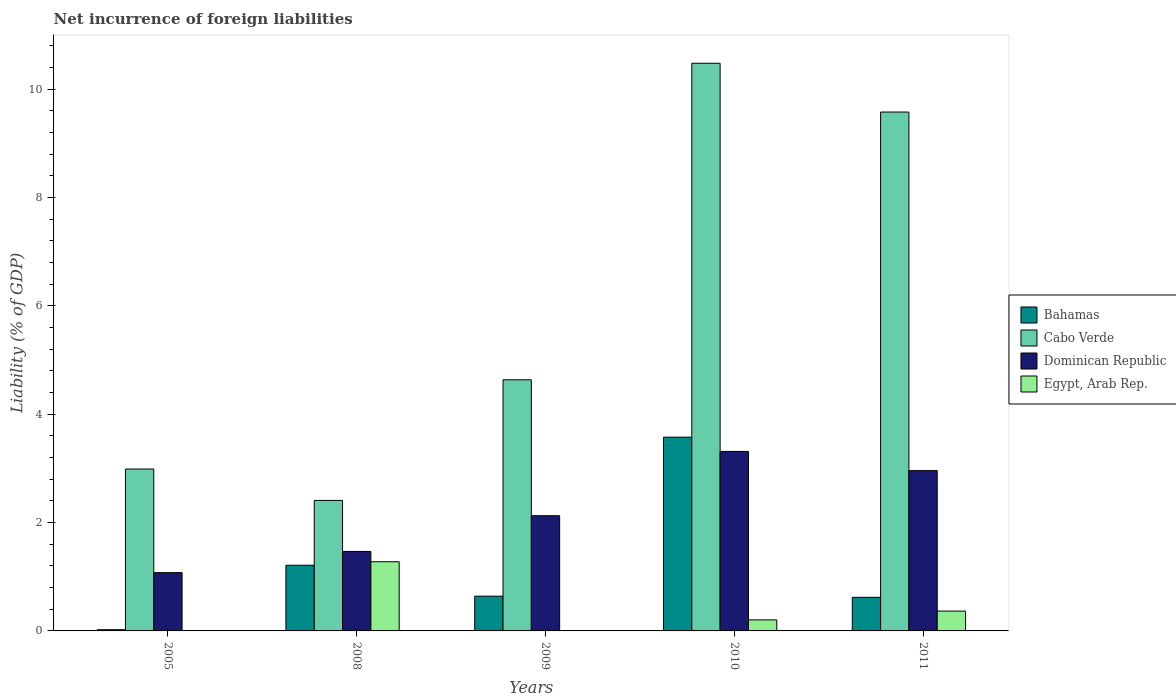How many different coloured bars are there?
Offer a very short reply. 4. Are the number of bars on each tick of the X-axis equal?
Your response must be concise. No. How many bars are there on the 1st tick from the left?
Offer a terse response. 3. How many bars are there on the 1st tick from the right?
Offer a terse response. 4. What is the net incurrence of foreign liabilities in Dominican Republic in 2010?
Your answer should be compact. 3.31. Across all years, what is the maximum net incurrence of foreign liabilities in Egypt, Arab Rep.?
Your answer should be compact. 1.28. Across all years, what is the minimum net incurrence of foreign liabilities in Cabo Verde?
Make the answer very short. 2.41. In which year was the net incurrence of foreign liabilities in Bahamas maximum?
Provide a succinct answer. 2010. What is the total net incurrence of foreign liabilities in Egypt, Arab Rep. in the graph?
Offer a terse response. 1.85. What is the difference between the net incurrence of foreign liabilities in Egypt, Arab Rep. in 2010 and that in 2011?
Your response must be concise. -0.16. What is the difference between the net incurrence of foreign liabilities in Bahamas in 2005 and the net incurrence of foreign liabilities in Cabo Verde in 2009?
Ensure brevity in your answer.  -4.61. What is the average net incurrence of foreign liabilities in Dominican Republic per year?
Provide a succinct answer. 2.19. In the year 2010, what is the difference between the net incurrence of foreign liabilities in Egypt, Arab Rep. and net incurrence of foreign liabilities in Cabo Verde?
Give a very brief answer. -10.28. In how many years, is the net incurrence of foreign liabilities in Dominican Republic greater than 7.2 %?
Give a very brief answer. 0. What is the ratio of the net incurrence of foreign liabilities in Bahamas in 2008 to that in 2009?
Ensure brevity in your answer.  1.89. Is the net incurrence of foreign liabilities in Bahamas in 2009 less than that in 2010?
Give a very brief answer. Yes. What is the difference between the highest and the second highest net incurrence of foreign liabilities in Cabo Verde?
Ensure brevity in your answer.  0.9. What is the difference between the highest and the lowest net incurrence of foreign liabilities in Egypt, Arab Rep.?
Offer a terse response. 1.28. In how many years, is the net incurrence of foreign liabilities in Bahamas greater than the average net incurrence of foreign liabilities in Bahamas taken over all years?
Provide a succinct answer. 1. Is the sum of the net incurrence of foreign liabilities in Dominican Republic in 2008 and 2009 greater than the maximum net incurrence of foreign liabilities in Cabo Verde across all years?
Your answer should be very brief. No. Is it the case that in every year, the sum of the net incurrence of foreign liabilities in Cabo Verde and net incurrence of foreign liabilities in Bahamas is greater than the sum of net incurrence of foreign liabilities in Dominican Republic and net incurrence of foreign liabilities in Egypt, Arab Rep.?
Provide a short and direct response. No. What is the difference between two consecutive major ticks on the Y-axis?
Keep it short and to the point. 2. Does the graph contain any zero values?
Offer a very short reply. Yes. Does the graph contain grids?
Provide a short and direct response. No. What is the title of the graph?
Your response must be concise. Net incurrence of foreign liabilities. What is the label or title of the Y-axis?
Offer a terse response. Liability (% of GDP). What is the Liability (% of GDP) in Bahamas in 2005?
Keep it short and to the point. 0.02. What is the Liability (% of GDP) in Cabo Verde in 2005?
Provide a succinct answer. 2.99. What is the Liability (% of GDP) of Dominican Republic in 2005?
Keep it short and to the point. 1.08. What is the Liability (% of GDP) in Bahamas in 2008?
Provide a short and direct response. 1.21. What is the Liability (% of GDP) in Cabo Verde in 2008?
Your response must be concise. 2.41. What is the Liability (% of GDP) in Dominican Republic in 2008?
Your response must be concise. 1.47. What is the Liability (% of GDP) of Egypt, Arab Rep. in 2008?
Your answer should be compact. 1.28. What is the Liability (% of GDP) of Bahamas in 2009?
Offer a very short reply. 0.64. What is the Liability (% of GDP) of Cabo Verde in 2009?
Keep it short and to the point. 4.64. What is the Liability (% of GDP) of Dominican Republic in 2009?
Make the answer very short. 2.13. What is the Liability (% of GDP) of Bahamas in 2010?
Provide a short and direct response. 3.58. What is the Liability (% of GDP) in Cabo Verde in 2010?
Give a very brief answer. 10.48. What is the Liability (% of GDP) of Dominican Republic in 2010?
Ensure brevity in your answer.  3.31. What is the Liability (% of GDP) in Egypt, Arab Rep. in 2010?
Offer a terse response. 0.2. What is the Liability (% of GDP) of Bahamas in 2011?
Keep it short and to the point. 0.62. What is the Liability (% of GDP) of Cabo Verde in 2011?
Ensure brevity in your answer.  9.58. What is the Liability (% of GDP) in Dominican Republic in 2011?
Keep it short and to the point. 2.96. What is the Liability (% of GDP) in Egypt, Arab Rep. in 2011?
Your response must be concise. 0.37. Across all years, what is the maximum Liability (% of GDP) of Bahamas?
Provide a succinct answer. 3.58. Across all years, what is the maximum Liability (% of GDP) in Cabo Verde?
Your answer should be very brief. 10.48. Across all years, what is the maximum Liability (% of GDP) in Dominican Republic?
Ensure brevity in your answer.  3.31. Across all years, what is the maximum Liability (% of GDP) in Egypt, Arab Rep.?
Ensure brevity in your answer.  1.28. Across all years, what is the minimum Liability (% of GDP) in Bahamas?
Ensure brevity in your answer.  0.02. Across all years, what is the minimum Liability (% of GDP) of Cabo Verde?
Offer a very short reply. 2.41. Across all years, what is the minimum Liability (% of GDP) in Dominican Republic?
Your answer should be compact. 1.08. Across all years, what is the minimum Liability (% of GDP) in Egypt, Arab Rep.?
Offer a very short reply. 0. What is the total Liability (% of GDP) of Bahamas in the graph?
Provide a short and direct response. 6.07. What is the total Liability (% of GDP) in Cabo Verde in the graph?
Provide a short and direct response. 30.1. What is the total Liability (% of GDP) in Dominican Republic in the graph?
Offer a terse response. 10.95. What is the total Liability (% of GDP) in Egypt, Arab Rep. in the graph?
Your response must be concise. 1.85. What is the difference between the Liability (% of GDP) in Bahamas in 2005 and that in 2008?
Your answer should be very brief. -1.19. What is the difference between the Liability (% of GDP) in Cabo Verde in 2005 and that in 2008?
Provide a short and direct response. 0.58. What is the difference between the Liability (% of GDP) in Dominican Republic in 2005 and that in 2008?
Provide a succinct answer. -0.39. What is the difference between the Liability (% of GDP) in Bahamas in 2005 and that in 2009?
Give a very brief answer. -0.62. What is the difference between the Liability (% of GDP) in Cabo Verde in 2005 and that in 2009?
Ensure brevity in your answer.  -1.65. What is the difference between the Liability (% of GDP) in Dominican Republic in 2005 and that in 2009?
Your answer should be very brief. -1.05. What is the difference between the Liability (% of GDP) of Bahamas in 2005 and that in 2010?
Keep it short and to the point. -3.56. What is the difference between the Liability (% of GDP) of Cabo Verde in 2005 and that in 2010?
Ensure brevity in your answer.  -7.49. What is the difference between the Liability (% of GDP) of Dominican Republic in 2005 and that in 2010?
Give a very brief answer. -2.24. What is the difference between the Liability (% of GDP) in Bahamas in 2005 and that in 2011?
Offer a very short reply. -0.6. What is the difference between the Liability (% of GDP) in Cabo Verde in 2005 and that in 2011?
Your answer should be very brief. -6.59. What is the difference between the Liability (% of GDP) of Dominican Republic in 2005 and that in 2011?
Offer a very short reply. -1.88. What is the difference between the Liability (% of GDP) in Bahamas in 2008 and that in 2009?
Provide a short and direct response. 0.57. What is the difference between the Liability (% of GDP) in Cabo Verde in 2008 and that in 2009?
Provide a succinct answer. -2.23. What is the difference between the Liability (% of GDP) in Dominican Republic in 2008 and that in 2009?
Your response must be concise. -0.66. What is the difference between the Liability (% of GDP) in Bahamas in 2008 and that in 2010?
Your answer should be compact. -2.36. What is the difference between the Liability (% of GDP) of Cabo Verde in 2008 and that in 2010?
Give a very brief answer. -8.07. What is the difference between the Liability (% of GDP) in Dominican Republic in 2008 and that in 2010?
Give a very brief answer. -1.85. What is the difference between the Liability (% of GDP) in Egypt, Arab Rep. in 2008 and that in 2010?
Your answer should be very brief. 1.07. What is the difference between the Liability (% of GDP) in Bahamas in 2008 and that in 2011?
Ensure brevity in your answer.  0.59. What is the difference between the Liability (% of GDP) in Cabo Verde in 2008 and that in 2011?
Give a very brief answer. -7.17. What is the difference between the Liability (% of GDP) of Dominican Republic in 2008 and that in 2011?
Provide a succinct answer. -1.49. What is the difference between the Liability (% of GDP) in Egypt, Arab Rep. in 2008 and that in 2011?
Your answer should be very brief. 0.91. What is the difference between the Liability (% of GDP) in Bahamas in 2009 and that in 2010?
Your answer should be very brief. -2.94. What is the difference between the Liability (% of GDP) in Cabo Verde in 2009 and that in 2010?
Your answer should be compact. -5.84. What is the difference between the Liability (% of GDP) in Dominican Republic in 2009 and that in 2010?
Provide a succinct answer. -1.19. What is the difference between the Liability (% of GDP) in Bahamas in 2009 and that in 2011?
Your answer should be compact. 0.02. What is the difference between the Liability (% of GDP) in Cabo Verde in 2009 and that in 2011?
Ensure brevity in your answer.  -4.94. What is the difference between the Liability (% of GDP) of Dominican Republic in 2009 and that in 2011?
Keep it short and to the point. -0.83. What is the difference between the Liability (% of GDP) of Bahamas in 2010 and that in 2011?
Give a very brief answer. 2.96. What is the difference between the Liability (% of GDP) of Cabo Verde in 2010 and that in 2011?
Offer a very short reply. 0.9. What is the difference between the Liability (% of GDP) of Dominican Republic in 2010 and that in 2011?
Offer a terse response. 0.35. What is the difference between the Liability (% of GDP) of Egypt, Arab Rep. in 2010 and that in 2011?
Offer a terse response. -0.16. What is the difference between the Liability (% of GDP) of Bahamas in 2005 and the Liability (% of GDP) of Cabo Verde in 2008?
Provide a short and direct response. -2.39. What is the difference between the Liability (% of GDP) in Bahamas in 2005 and the Liability (% of GDP) in Dominican Republic in 2008?
Your answer should be compact. -1.45. What is the difference between the Liability (% of GDP) of Bahamas in 2005 and the Liability (% of GDP) of Egypt, Arab Rep. in 2008?
Give a very brief answer. -1.26. What is the difference between the Liability (% of GDP) in Cabo Verde in 2005 and the Liability (% of GDP) in Dominican Republic in 2008?
Offer a terse response. 1.52. What is the difference between the Liability (% of GDP) of Cabo Verde in 2005 and the Liability (% of GDP) of Egypt, Arab Rep. in 2008?
Provide a succinct answer. 1.71. What is the difference between the Liability (% of GDP) of Dominican Republic in 2005 and the Liability (% of GDP) of Egypt, Arab Rep. in 2008?
Give a very brief answer. -0.2. What is the difference between the Liability (% of GDP) in Bahamas in 2005 and the Liability (% of GDP) in Cabo Verde in 2009?
Give a very brief answer. -4.62. What is the difference between the Liability (% of GDP) in Bahamas in 2005 and the Liability (% of GDP) in Dominican Republic in 2009?
Provide a succinct answer. -2.11. What is the difference between the Liability (% of GDP) of Cabo Verde in 2005 and the Liability (% of GDP) of Dominican Republic in 2009?
Offer a terse response. 0.86. What is the difference between the Liability (% of GDP) in Bahamas in 2005 and the Liability (% of GDP) in Cabo Verde in 2010?
Ensure brevity in your answer.  -10.46. What is the difference between the Liability (% of GDP) of Bahamas in 2005 and the Liability (% of GDP) of Dominican Republic in 2010?
Offer a very short reply. -3.29. What is the difference between the Liability (% of GDP) in Bahamas in 2005 and the Liability (% of GDP) in Egypt, Arab Rep. in 2010?
Give a very brief answer. -0.18. What is the difference between the Liability (% of GDP) in Cabo Verde in 2005 and the Liability (% of GDP) in Dominican Republic in 2010?
Keep it short and to the point. -0.33. What is the difference between the Liability (% of GDP) in Cabo Verde in 2005 and the Liability (% of GDP) in Egypt, Arab Rep. in 2010?
Give a very brief answer. 2.79. What is the difference between the Liability (% of GDP) in Dominican Republic in 2005 and the Liability (% of GDP) in Egypt, Arab Rep. in 2010?
Offer a terse response. 0.87. What is the difference between the Liability (% of GDP) of Bahamas in 2005 and the Liability (% of GDP) of Cabo Verde in 2011?
Provide a short and direct response. -9.56. What is the difference between the Liability (% of GDP) in Bahamas in 2005 and the Liability (% of GDP) in Dominican Republic in 2011?
Give a very brief answer. -2.94. What is the difference between the Liability (% of GDP) in Bahamas in 2005 and the Liability (% of GDP) in Egypt, Arab Rep. in 2011?
Offer a terse response. -0.34. What is the difference between the Liability (% of GDP) of Cabo Verde in 2005 and the Liability (% of GDP) of Dominican Republic in 2011?
Make the answer very short. 0.03. What is the difference between the Liability (% of GDP) of Cabo Verde in 2005 and the Liability (% of GDP) of Egypt, Arab Rep. in 2011?
Keep it short and to the point. 2.62. What is the difference between the Liability (% of GDP) in Dominican Republic in 2005 and the Liability (% of GDP) in Egypt, Arab Rep. in 2011?
Offer a terse response. 0.71. What is the difference between the Liability (% of GDP) in Bahamas in 2008 and the Liability (% of GDP) in Cabo Verde in 2009?
Your response must be concise. -3.42. What is the difference between the Liability (% of GDP) in Bahamas in 2008 and the Liability (% of GDP) in Dominican Republic in 2009?
Offer a very short reply. -0.91. What is the difference between the Liability (% of GDP) in Cabo Verde in 2008 and the Liability (% of GDP) in Dominican Republic in 2009?
Give a very brief answer. 0.28. What is the difference between the Liability (% of GDP) of Bahamas in 2008 and the Liability (% of GDP) of Cabo Verde in 2010?
Your response must be concise. -9.27. What is the difference between the Liability (% of GDP) of Bahamas in 2008 and the Liability (% of GDP) of Dominican Republic in 2010?
Provide a short and direct response. -2.1. What is the difference between the Liability (% of GDP) in Bahamas in 2008 and the Liability (% of GDP) in Egypt, Arab Rep. in 2010?
Your answer should be very brief. 1.01. What is the difference between the Liability (% of GDP) of Cabo Verde in 2008 and the Liability (% of GDP) of Dominican Republic in 2010?
Your answer should be very brief. -0.9. What is the difference between the Liability (% of GDP) of Cabo Verde in 2008 and the Liability (% of GDP) of Egypt, Arab Rep. in 2010?
Ensure brevity in your answer.  2.21. What is the difference between the Liability (% of GDP) in Dominican Republic in 2008 and the Liability (% of GDP) in Egypt, Arab Rep. in 2010?
Keep it short and to the point. 1.26. What is the difference between the Liability (% of GDP) in Bahamas in 2008 and the Liability (% of GDP) in Cabo Verde in 2011?
Keep it short and to the point. -8.37. What is the difference between the Liability (% of GDP) of Bahamas in 2008 and the Liability (% of GDP) of Dominican Republic in 2011?
Offer a terse response. -1.75. What is the difference between the Liability (% of GDP) of Bahamas in 2008 and the Liability (% of GDP) of Egypt, Arab Rep. in 2011?
Your answer should be compact. 0.85. What is the difference between the Liability (% of GDP) in Cabo Verde in 2008 and the Liability (% of GDP) in Dominican Republic in 2011?
Make the answer very short. -0.55. What is the difference between the Liability (% of GDP) of Cabo Verde in 2008 and the Liability (% of GDP) of Egypt, Arab Rep. in 2011?
Your answer should be very brief. 2.04. What is the difference between the Liability (% of GDP) in Dominican Republic in 2008 and the Liability (% of GDP) in Egypt, Arab Rep. in 2011?
Your response must be concise. 1.1. What is the difference between the Liability (% of GDP) in Bahamas in 2009 and the Liability (% of GDP) in Cabo Verde in 2010?
Keep it short and to the point. -9.84. What is the difference between the Liability (% of GDP) of Bahamas in 2009 and the Liability (% of GDP) of Dominican Republic in 2010?
Offer a terse response. -2.67. What is the difference between the Liability (% of GDP) of Bahamas in 2009 and the Liability (% of GDP) of Egypt, Arab Rep. in 2010?
Offer a very short reply. 0.44. What is the difference between the Liability (% of GDP) in Cabo Verde in 2009 and the Liability (% of GDP) in Dominican Republic in 2010?
Offer a terse response. 1.32. What is the difference between the Liability (% of GDP) of Cabo Verde in 2009 and the Liability (% of GDP) of Egypt, Arab Rep. in 2010?
Make the answer very short. 4.43. What is the difference between the Liability (% of GDP) of Dominican Republic in 2009 and the Liability (% of GDP) of Egypt, Arab Rep. in 2010?
Provide a short and direct response. 1.92. What is the difference between the Liability (% of GDP) in Bahamas in 2009 and the Liability (% of GDP) in Cabo Verde in 2011?
Make the answer very short. -8.94. What is the difference between the Liability (% of GDP) in Bahamas in 2009 and the Liability (% of GDP) in Dominican Republic in 2011?
Ensure brevity in your answer.  -2.32. What is the difference between the Liability (% of GDP) of Bahamas in 2009 and the Liability (% of GDP) of Egypt, Arab Rep. in 2011?
Your answer should be very brief. 0.28. What is the difference between the Liability (% of GDP) in Cabo Verde in 2009 and the Liability (% of GDP) in Dominican Republic in 2011?
Offer a very short reply. 1.68. What is the difference between the Liability (% of GDP) in Cabo Verde in 2009 and the Liability (% of GDP) in Egypt, Arab Rep. in 2011?
Your answer should be compact. 4.27. What is the difference between the Liability (% of GDP) of Dominican Republic in 2009 and the Liability (% of GDP) of Egypt, Arab Rep. in 2011?
Keep it short and to the point. 1.76. What is the difference between the Liability (% of GDP) of Bahamas in 2010 and the Liability (% of GDP) of Cabo Verde in 2011?
Make the answer very short. -6. What is the difference between the Liability (% of GDP) in Bahamas in 2010 and the Liability (% of GDP) in Dominican Republic in 2011?
Make the answer very short. 0.62. What is the difference between the Liability (% of GDP) in Bahamas in 2010 and the Liability (% of GDP) in Egypt, Arab Rep. in 2011?
Your answer should be very brief. 3.21. What is the difference between the Liability (% of GDP) of Cabo Verde in 2010 and the Liability (% of GDP) of Dominican Republic in 2011?
Your answer should be very brief. 7.52. What is the difference between the Liability (% of GDP) in Cabo Verde in 2010 and the Liability (% of GDP) in Egypt, Arab Rep. in 2011?
Provide a short and direct response. 10.11. What is the difference between the Liability (% of GDP) of Dominican Republic in 2010 and the Liability (% of GDP) of Egypt, Arab Rep. in 2011?
Provide a succinct answer. 2.95. What is the average Liability (% of GDP) in Bahamas per year?
Your answer should be compact. 1.21. What is the average Liability (% of GDP) in Cabo Verde per year?
Give a very brief answer. 6.02. What is the average Liability (% of GDP) of Dominican Republic per year?
Keep it short and to the point. 2.19. What is the average Liability (% of GDP) in Egypt, Arab Rep. per year?
Your answer should be very brief. 0.37. In the year 2005, what is the difference between the Liability (% of GDP) in Bahamas and Liability (% of GDP) in Cabo Verde?
Keep it short and to the point. -2.97. In the year 2005, what is the difference between the Liability (% of GDP) in Bahamas and Liability (% of GDP) in Dominican Republic?
Provide a succinct answer. -1.05. In the year 2005, what is the difference between the Liability (% of GDP) in Cabo Verde and Liability (% of GDP) in Dominican Republic?
Your answer should be compact. 1.91. In the year 2008, what is the difference between the Liability (% of GDP) of Bahamas and Liability (% of GDP) of Cabo Verde?
Offer a very short reply. -1.2. In the year 2008, what is the difference between the Liability (% of GDP) of Bahamas and Liability (% of GDP) of Dominican Republic?
Your answer should be compact. -0.26. In the year 2008, what is the difference between the Liability (% of GDP) in Bahamas and Liability (% of GDP) in Egypt, Arab Rep.?
Your answer should be very brief. -0.06. In the year 2008, what is the difference between the Liability (% of GDP) in Cabo Verde and Liability (% of GDP) in Dominican Republic?
Offer a very short reply. 0.94. In the year 2008, what is the difference between the Liability (% of GDP) of Cabo Verde and Liability (% of GDP) of Egypt, Arab Rep.?
Keep it short and to the point. 1.13. In the year 2008, what is the difference between the Liability (% of GDP) of Dominican Republic and Liability (% of GDP) of Egypt, Arab Rep.?
Offer a very short reply. 0.19. In the year 2009, what is the difference between the Liability (% of GDP) of Bahamas and Liability (% of GDP) of Cabo Verde?
Give a very brief answer. -4. In the year 2009, what is the difference between the Liability (% of GDP) in Bahamas and Liability (% of GDP) in Dominican Republic?
Give a very brief answer. -1.49. In the year 2009, what is the difference between the Liability (% of GDP) of Cabo Verde and Liability (% of GDP) of Dominican Republic?
Your answer should be very brief. 2.51. In the year 2010, what is the difference between the Liability (% of GDP) in Bahamas and Liability (% of GDP) in Cabo Verde?
Ensure brevity in your answer.  -6.9. In the year 2010, what is the difference between the Liability (% of GDP) of Bahamas and Liability (% of GDP) of Dominican Republic?
Offer a very short reply. 0.26. In the year 2010, what is the difference between the Liability (% of GDP) of Bahamas and Liability (% of GDP) of Egypt, Arab Rep.?
Your answer should be compact. 3.37. In the year 2010, what is the difference between the Liability (% of GDP) of Cabo Verde and Liability (% of GDP) of Dominican Republic?
Your response must be concise. 7.17. In the year 2010, what is the difference between the Liability (% of GDP) of Cabo Verde and Liability (% of GDP) of Egypt, Arab Rep.?
Offer a very short reply. 10.28. In the year 2010, what is the difference between the Liability (% of GDP) of Dominican Republic and Liability (% of GDP) of Egypt, Arab Rep.?
Keep it short and to the point. 3.11. In the year 2011, what is the difference between the Liability (% of GDP) of Bahamas and Liability (% of GDP) of Cabo Verde?
Keep it short and to the point. -8.96. In the year 2011, what is the difference between the Liability (% of GDP) of Bahamas and Liability (% of GDP) of Dominican Republic?
Give a very brief answer. -2.34. In the year 2011, what is the difference between the Liability (% of GDP) of Bahamas and Liability (% of GDP) of Egypt, Arab Rep.?
Provide a succinct answer. 0.25. In the year 2011, what is the difference between the Liability (% of GDP) of Cabo Verde and Liability (% of GDP) of Dominican Republic?
Provide a succinct answer. 6.62. In the year 2011, what is the difference between the Liability (% of GDP) in Cabo Verde and Liability (% of GDP) in Egypt, Arab Rep.?
Your answer should be compact. 9.21. In the year 2011, what is the difference between the Liability (% of GDP) of Dominican Republic and Liability (% of GDP) of Egypt, Arab Rep.?
Offer a very short reply. 2.59. What is the ratio of the Liability (% of GDP) of Bahamas in 2005 to that in 2008?
Make the answer very short. 0.02. What is the ratio of the Liability (% of GDP) in Cabo Verde in 2005 to that in 2008?
Offer a terse response. 1.24. What is the ratio of the Liability (% of GDP) in Dominican Republic in 2005 to that in 2008?
Offer a terse response. 0.73. What is the ratio of the Liability (% of GDP) in Bahamas in 2005 to that in 2009?
Ensure brevity in your answer.  0.03. What is the ratio of the Liability (% of GDP) of Cabo Verde in 2005 to that in 2009?
Your response must be concise. 0.64. What is the ratio of the Liability (% of GDP) in Dominican Republic in 2005 to that in 2009?
Keep it short and to the point. 0.51. What is the ratio of the Liability (% of GDP) of Bahamas in 2005 to that in 2010?
Ensure brevity in your answer.  0.01. What is the ratio of the Liability (% of GDP) in Cabo Verde in 2005 to that in 2010?
Keep it short and to the point. 0.29. What is the ratio of the Liability (% of GDP) of Dominican Republic in 2005 to that in 2010?
Keep it short and to the point. 0.32. What is the ratio of the Liability (% of GDP) of Bahamas in 2005 to that in 2011?
Ensure brevity in your answer.  0.04. What is the ratio of the Liability (% of GDP) in Cabo Verde in 2005 to that in 2011?
Provide a succinct answer. 0.31. What is the ratio of the Liability (% of GDP) in Dominican Republic in 2005 to that in 2011?
Provide a short and direct response. 0.36. What is the ratio of the Liability (% of GDP) of Bahamas in 2008 to that in 2009?
Make the answer very short. 1.89. What is the ratio of the Liability (% of GDP) of Cabo Verde in 2008 to that in 2009?
Your answer should be compact. 0.52. What is the ratio of the Liability (% of GDP) of Dominican Republic in 2008 to that in 2009?
Offer a very short reply. 0.69. What is the ratio of the Liability (% of GDP) in Bahamas in 2008 to that in 2010?
Offer a terse response. 0.34. What is the ratio of the Liability (% of GDP) in Cabo Verde in 2008 to that in 2010?
Provide a short and direct response. 0.23. What is the ratio of the Liability (% of GDP) of Dominican Republic in 2008 to that in 2010?
Your response must be concise. 0.44. What is the ratio of the Liability (% of GDP) in Egypt, Arab Rep. in 2008 to that in 2010?
Your answer should be compact. 6.27. What is the ratio of the Liability (% of GDP) in Bahamas in 2008 to that in 2011?
Your answer should be compact. 1.96. What is the ratio of the Liability (% of GDP) in Cabo Verde in 2008 to that in 2011?
Offer a very short reply. 0.25. What is the ratio of the Liability (% of GDP) in Dominican Republic in 2008 to that in 2011?
Your answer should be very brief. 0.5. What is the ratio of the Liability (% of GDP) of Egypt, Arab Rep. in 2008 to that in 2011?
Provide a succinct answer. 3.49. What is the ratio of the Liability (% of GDP) in Bahamas in 2009 to that in 2010?
Your answer should be very brief. 0.18. What is the ratio of the Liability (% of GDP) of Cabo Verde in 2009 to that in 2010?
Your answer should be compact. 0.44. What is the ratio of the Liability (% of GDP) in Dominican Republic in 2009 to that in 2010?
Ensure brevity in your answer.  0.64. What is the ratio of the Liability (% of GDP) of Bahamas in 2009 to that in 2011?
Keep it short and to the point. 1.03. What is the ratio of the Liability (% of GDP) of Cabo Verde in 2009 to that in 2011?
Ensure brevity in your answer.  0.48. What is the ratio of the Liability (% of GDP) in Dominican Republic in 2009 to that in 2011?
Keep it short and to the point. 0.72. What is the ratio of the Liability (% of GDP) of Bahamas in 2010 to that in 2011?
Offer a very short reply. 5.77. What is the ratio of the Liability (% of GDP) in Cabo Verde in 2010 to that in 2011?
Give a very brief answer. 1.09. What is the ratio of the Liability (% of GDP) in Dominican Republic in 2010 to that in 2011?
Keep it short and to the point. 1.12. What is the ratio of the Liability (% of GDP) in Egypt, Arab Rep. in 2010 to that in 2011?
Provide a succinct answer. 0.56. What is the difference between the highest and the second highest Liability (% of GDP) in Bahamas?
Your answer should be very brief. 2.36. What is the difference between the highest and the second highest Liability (% of GDP) of Cabo Verde?
Your answer should be very brief. 0.9. What is the difference between the highest and the second highest Liability (% of GDP) of Dominican Republic?
Give a very brief answer. 0.35. What is the difference between the highest and the second highest Liability (% of GDP) in Egypt, Arab Rep.?
Your answer should be very brief. 0.91. What is the difference between the highest and the lowest Liability (% of GDP) in Bahamas?
Your answer should be very brief. 3.56. What is the difference between the highest and the lowest Liability (% of GDP) in Cabo Verde?
Your response must be concise. 8.07. What is the difference between the highest and the lowest Liability (% of GDP) in Dominican Republic?
Your response must be concise. 2.24. What is the difference between the highest and the lowest Liability (% of GDP) of Egypt, Arab Rep.?
Your answer should be compact. 1.28. 